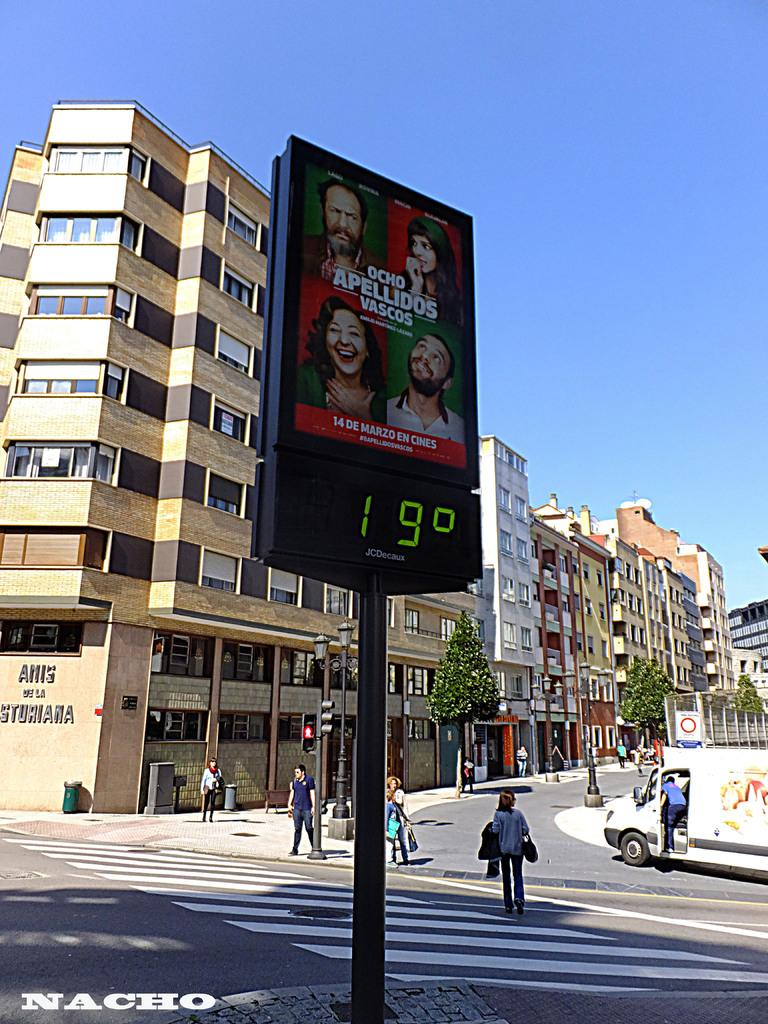<image>
Create a compact narrative representing the image presented. An advertisement over a digital display of the temperature reading 19 degrees 